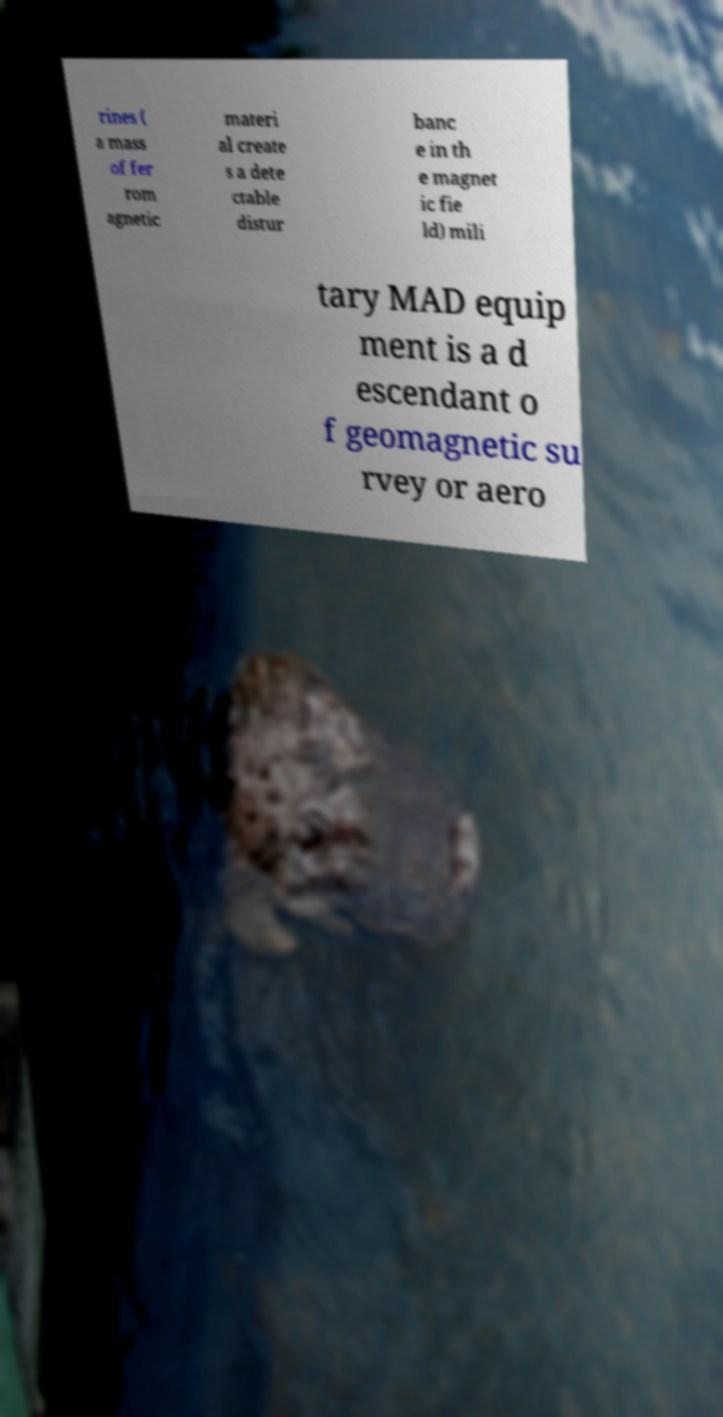For documentation purposes, I need the text within this image transcribed. Could you provide that? rines ( a mass of fer rom agnetic materi al create s a dete ctable distur banc e in th e magnet ic fie ld) mili tary MAD equip ment is a d escendant o f geomagnetic su rvey or aero 